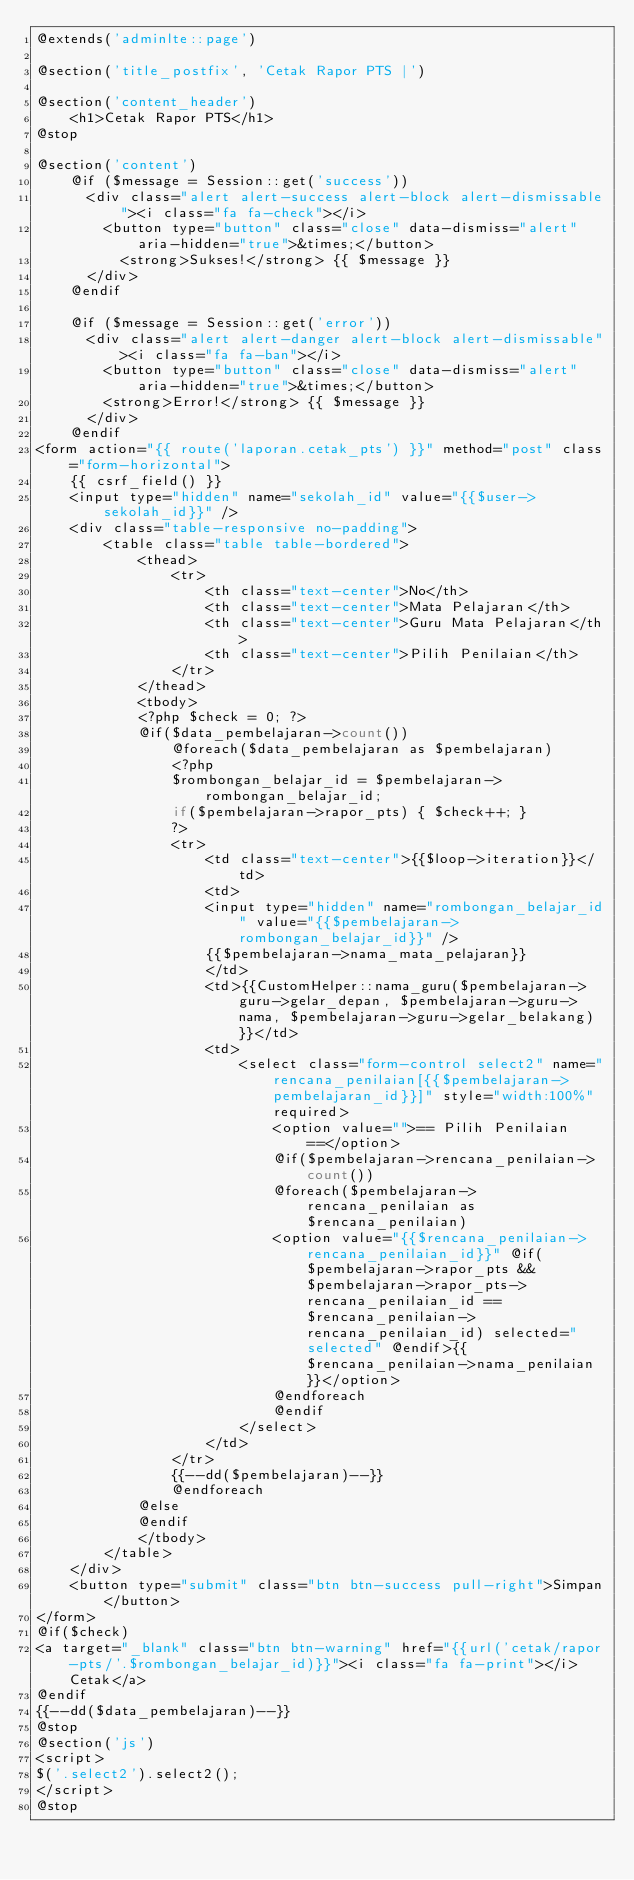Convert code to text. <code><loc_0><loc_0><loc_500><loc_500><_PHP_>@extends('adminlte::page')

@section('title_postfix', 'Cetak Rapor PTS |')

@section('content_header')
    <h1>Cetak Rapor PTS</h1>
@stop

@section('content')
	@if ($message = Session::get('success'))
      <div class="alert alert-success alert-block alert-dismissable"><i class="fa fa-check"></i>
        <button type="button" class="close" data-dismiss="alert" aria-hidden="true">&times;</button>
          <strong>Sukses!</strong> {{ $message }}
      </div>
    @endif

    @if ($message = Session::get('error'))
      <div class="alert alert-danger alert-block alert-dismissable"><i class="fa fa-ban"></i>
        <button type="button" class="close" data-dismiss="alert" aria-hidden="true">&times;</button>
        <strong>Error!</strong> {{ $message }}
      </div>
    @endif
<form action="{{ route('laporan.cetak_pts') }}" method="post" class="form-horizontal">
	{{ csrf_field() }}
	<input type="hidden" name="sekolah_id" value="{{$user->sekolah_id}}" />
	<div class="table-responsive no-padding">
		<table class="table table-bordered">
			<thead>
				<tr>
					<th class="text-center">No</th>
					<th class="text-center">Mata Pelajaran</th>
					<th class="text-center">Guru Mata Pelajaran</th>
					<th class="text-center">Pilih Penilaian</th>
				</tr>
			</thead>
			<tbody>
			<?php $check = 0; ?>
			@if($data_pembelajaran->count())
				@foreach($data_pembelajaran as $pembelajaran)
				<?php
				$rombongan_belajar_id = $pembelajaran->rombongan_belajar_id;
				if($pembelajaran->rapor_pts) { $check++; } 
				?>
				<tr>
					<td class="text-center">{{$loop->iteration}}</td>
					<td>
					<input type="hidden" name="rombongan_belajar_id" value="{{$pembelajaran->rombongan_belajar_id}}" />
					{{$pembelajaran->nama_mata_pelajaran}}
					</td>
					<td>{{CustomHelper::nama_guru($pembelajaran->guru->gelar_depan, $pembelajaran->guru->nama, $pembelajaran->guru->gelar_belakang)}}</td>
					<td>
						<select class="form-control select2" name="rencana_penilaian[{{$pembelajaran->pembelajaran_id}}]" style="width:100%" required>
							<option value="">== Pilih Penilaian ==</option>
							@if($pembelajaran->rencana_penilaian->count())
							@foreach($pembelajaran->rencana_penilaian as $rencana_penilaian)
							<option value="{{$rencana_penilaian->rencana_penilaian_id}}" @if($pembelajaran->rapor_pts && $pembelajaran->rapor_pts->rencana_penilaian_id == $rencana_penilaian->rencana_penilaian_id) selected="selected" @endif>{{$rencana_penilaian->nama_penilaian}}</option>
							@endforeach
							@endif
						</select>
					</td>
				</tr>
				{{--dd($pembelajaran)--}}
				@endforeach
			@else
			@endif
			</tbody>
		</table>
	</div>
	<button type="submit" class="btn btn-success pull-right">Simpan</button>
</form>
@if($check)
<a target="_blank" class="btn btn-warning" href="{{url('cetak/rapor-pts/'.$rombongan_belajar_id)}}"><i class="fa fa-print"></i> Cetak</a>
@endif
{{--dd($data_pembelajaran)--}}
@stop
@section('js')
<script>
$('.select2').select2();
</script>
@stop</code> 